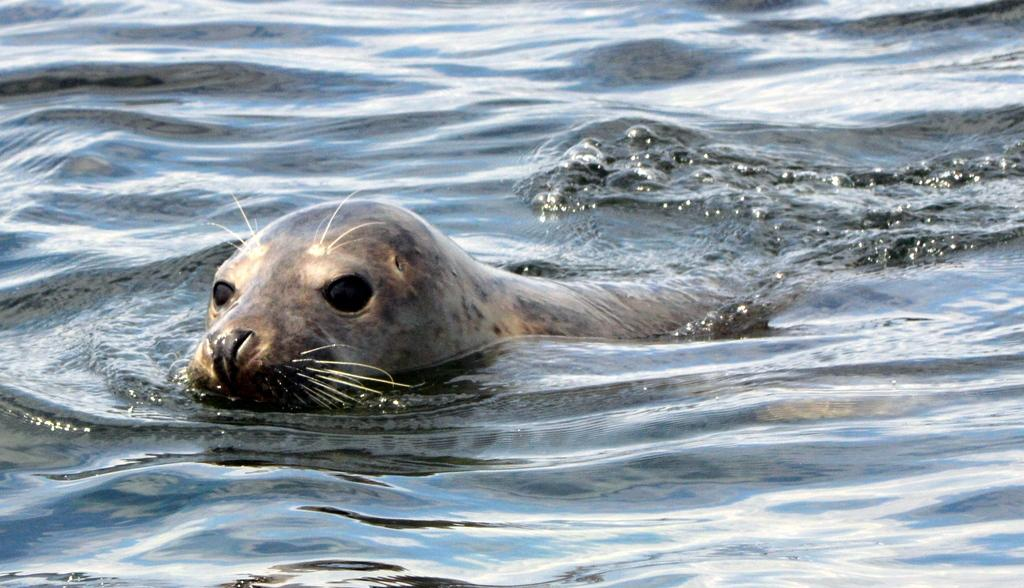What type of animal can be seen in the image? There is a seal in the water in the image. Where is the seal located in the image? The seal is in the water in the image. What type of calculator is the seal using in the image? There is no calculator present in the image; it features a seal in the water. How many fangs does the seal have in the image? Seals do not have fangs, and there is no need to count them in the image. 